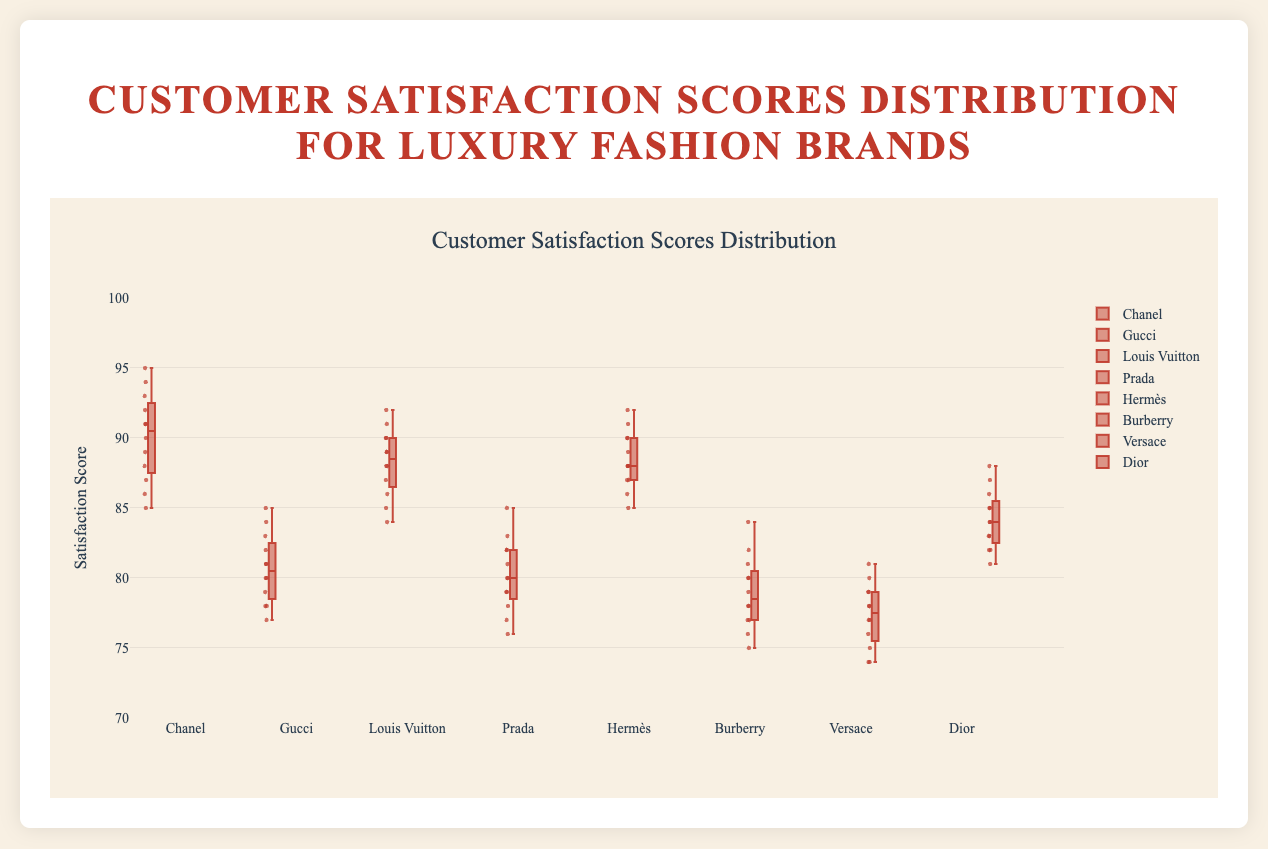What is the range of customer satisfaction scores for Chanel? The range of Chanel's scores is found by subtracting the minimum score from the maximum score: 95 - 85 = 10.
Answer: 10 Which brand has the highest median customer satisfaction score? To determine the highest median score, compare the median values (middle points of the data) of all brands. Chanel has the highest median score of 90.
Answer: Chanel What is the interquartile range (IQR) for Gucci? The IQR is calculated as the difference between the third quartile (Q3) and the first quartile (Q1). For Gucci, Q3 is around 83 and Q1 is about 78, so IQR = 83 - 78 = 5.
Answer: 5 How many brands have a median score of 88 or higher? Examine the median lines of each box plot and count the brands with medians at or above 88: Louis Vuitton, Chanel, Hermès, and Dior. Four brands meet this criterion.
Answer: 4 Which brand has the smallest range in satisfaction scores? The range is calculated by subtracting the minimum value from the maximum value for each brand. Hermès has the smallest range: 92 - 85 = 7.
Answer: Hermès Do any brands have outliers in their satisfaction scores? By inspecting the plots, outliers are identified by points that fall outside the whiskers of the box plots. None of the brands have outliers.
Answer: No Which two brands have the closest median satisfaction scores? Comparing all medians visually, Louis Vuitton and Hermès have very close median scores, both around 88.5.
Answer: Louis Vuitton and Hermès What is the median satisfaction score for Prada? The median score for Prada is the middle value of its data points, which is around 80.
Answer: 80 How does Dior's median score compare to Versace's median score? Dior's median score is around 84.5, while Versace's median score is about 77.5. Dior's median score is higher.
Answer: Dior's median is higher What is the maximum satisfaction score for Burberry? The top whisker or maximum point in Burberry's box plot shows the highest score is 84.
Answer: 84 